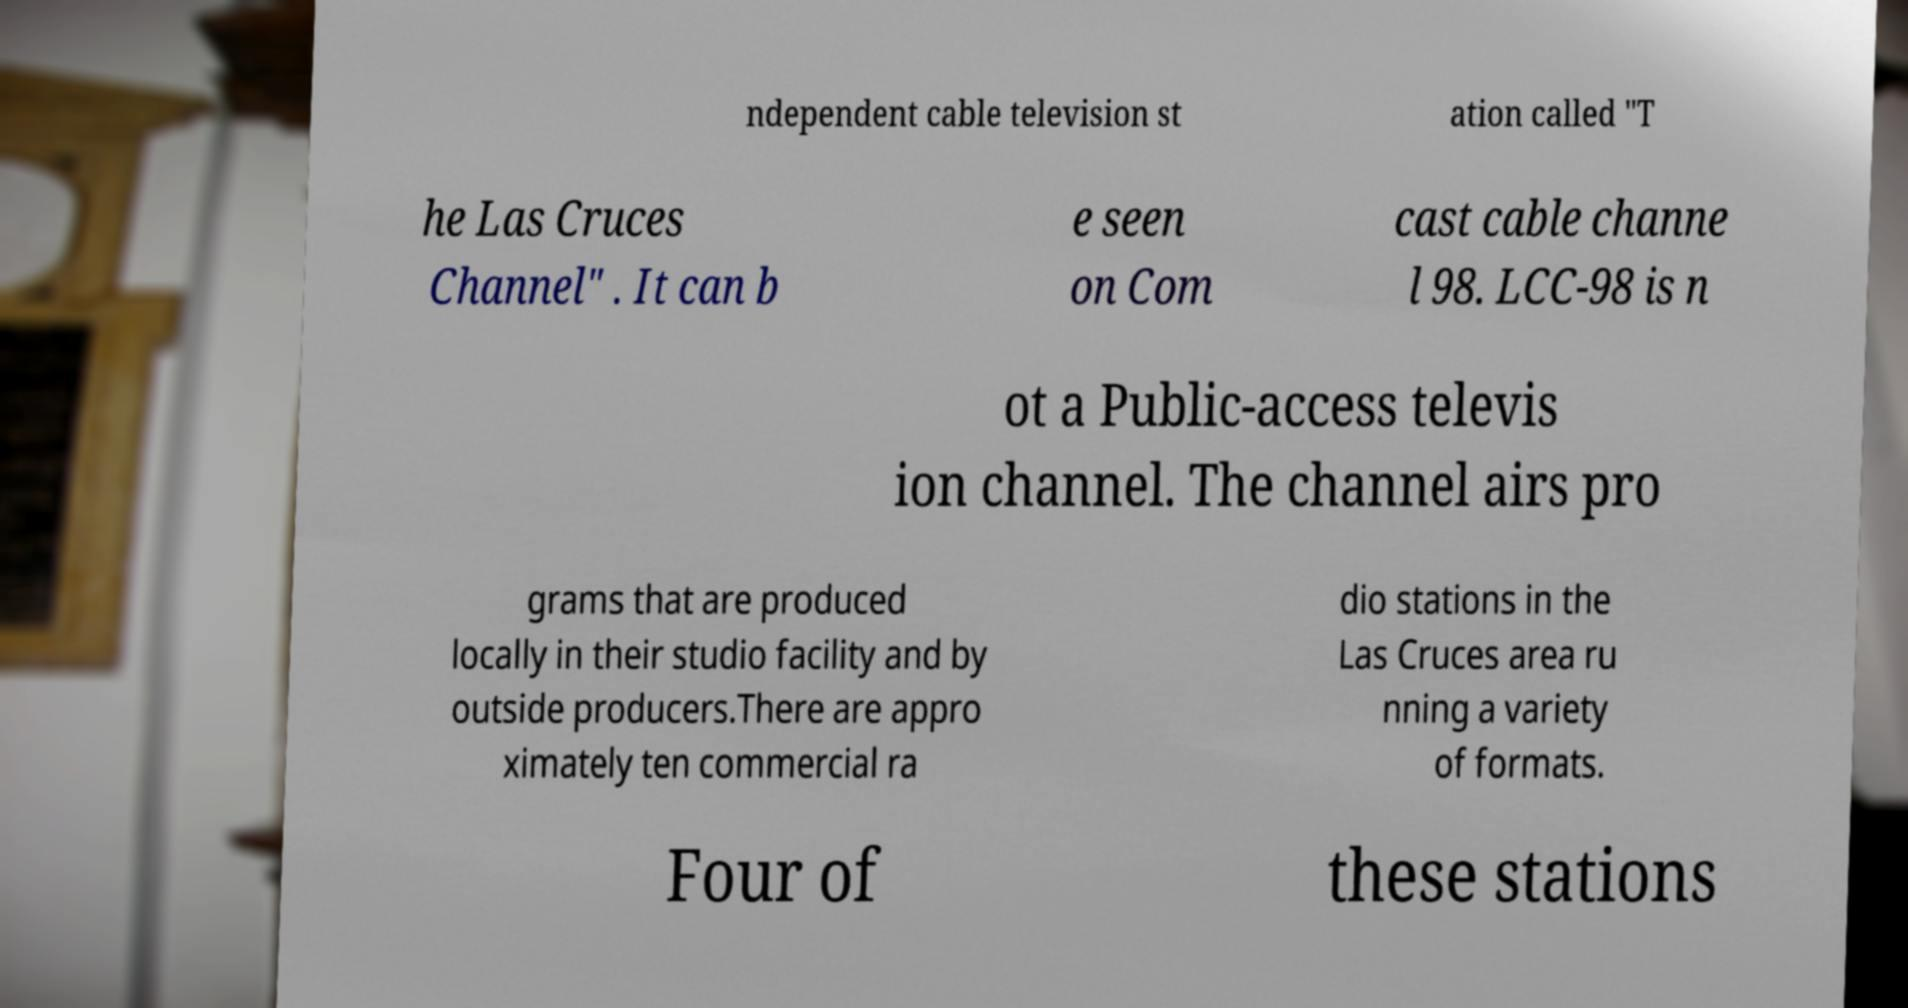For documentation purposes, I need the text within this image transcribed. Could you provide that? ndependent cable television st ation called "T he Las Cruces Channel" . It can b e seen on Com cast cable channe l 98. LCC-98 is n ot a Public-access televis ion channel. The channel airs pro grams that are produced locally in their studio facility and by outside producers.There are appro ximately ten commercial ra dio stations in the Las Cruces area ru nning a variety of formats. Four of these stations 